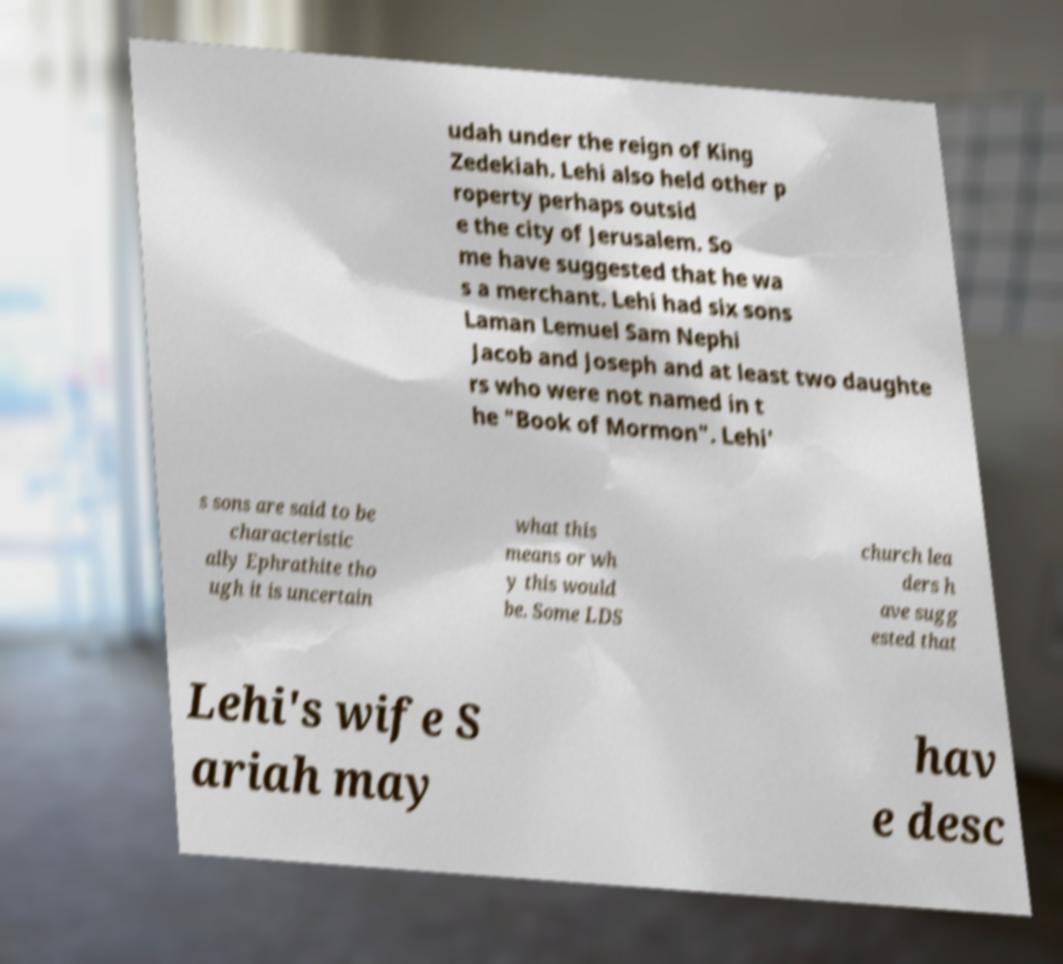I need the written content from this picture converted into text. Can you do that? udah under the reign of King Zedekiah. Lehi also held other p roperty perhaps outsid e the city of Jerusalem. So me have suggested that he wa s a merchant. Lehi had six sons Laman Lemuel Sam Nephi Jacob and Joseph and at least two daughte rs who were not named in t he "Book of Mormon". Lehi' s sons are said to be characteristic ally Ephrathite tho ugh it is uncertain what this means or wh y this would be. Some LDS church lea ders h ave sugg ested that Lehi's wife S ariah may hav e desc 